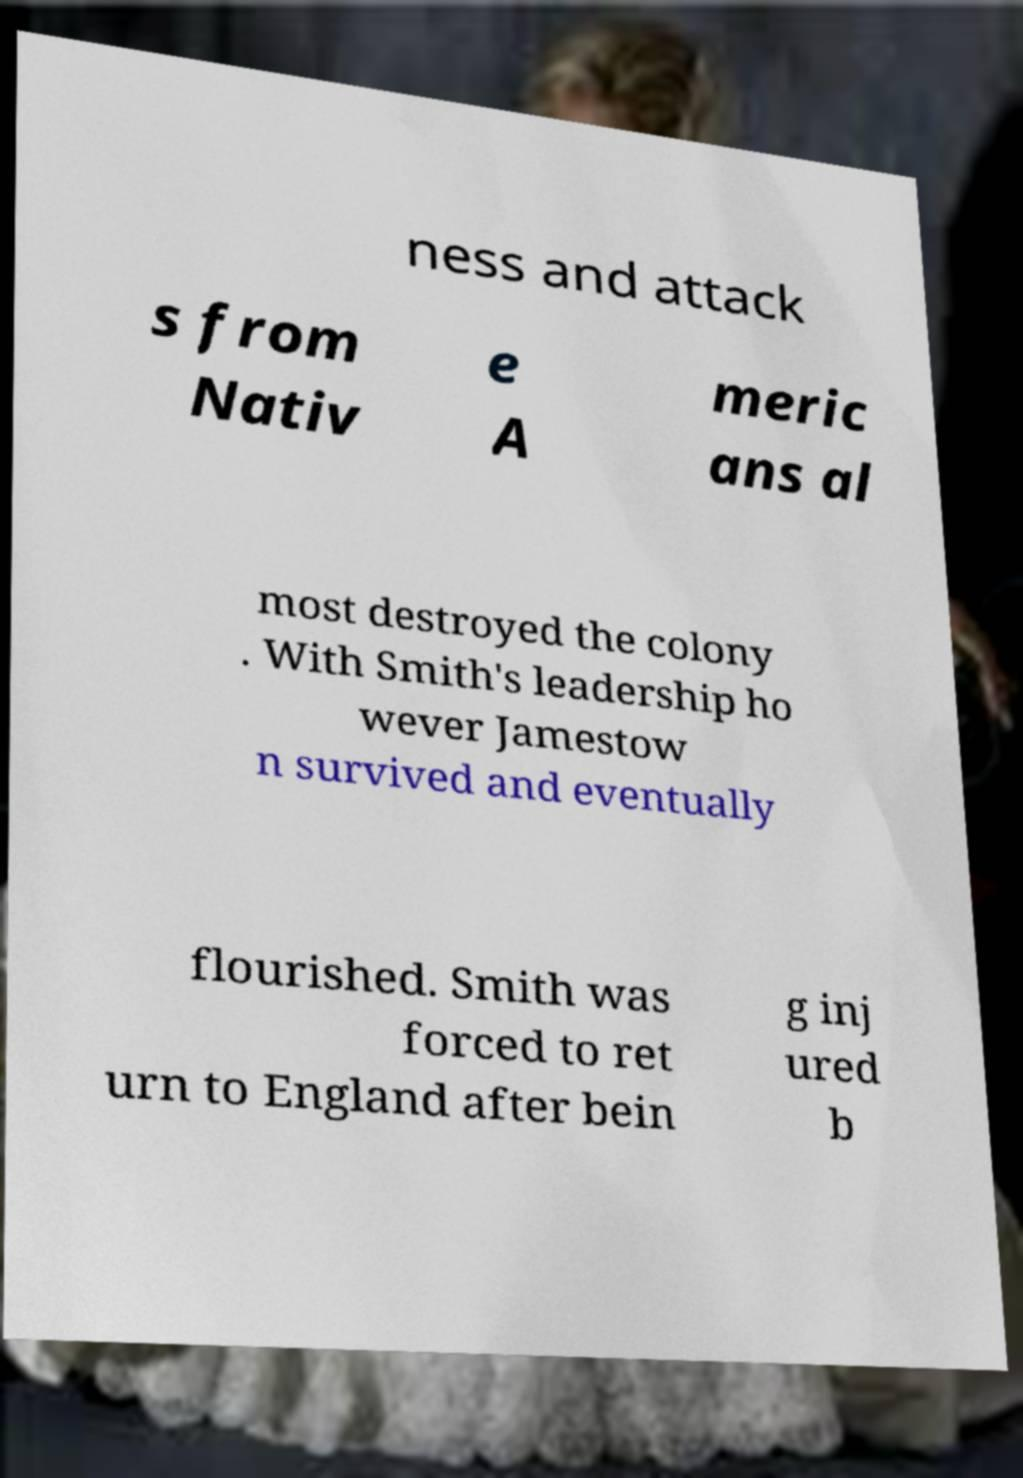What messages or text are displayed in this image? I need them in a readable, typed format. ness and attack s from Nativ e A meric ans al most destroyed the colony . With Smith's leadership ho wever Jamestow n survived and eventually flourished. Smith was forced to ret urn to England after bein g inj ured b 